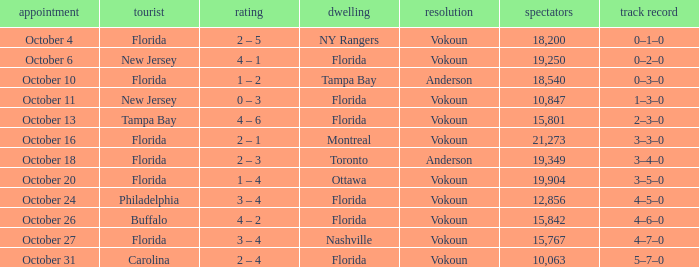Which team won when the visitor was Carolina? Vokoun. 